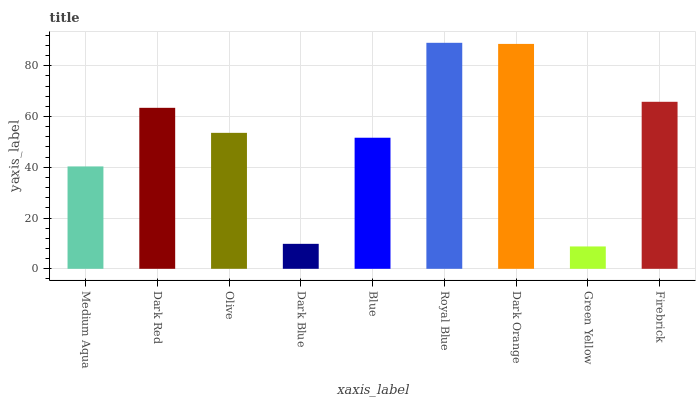Is Green Yellow the minimum?
Answer yes or no. Yes. Is Royal Blue the maximum?
Answer yes or no. Yes. Is Dark Red the minimum?
Answer yes or no. No. Is Dark Red the maximum?
Answer yes or no. No. Is Dark Red greater than Medium Aqua?
Answer yes or no. Yes. Is Medium Aqua less than Dark Red?
Answer yes or no. Yes. Is Medium Aqua greater than Dark Red?
Answer yes or no. No. Is Dark Red less than Medium Aqua?
Answer yes or no. No. Is Olive the high median?
Answer yes or no. Yes. Is Olive the low median?
Answer yes or no. Yes. Is Firebrick the high median?
Answer yes or no. No. Is Green Yellow the low median?
Answer yes or no. No. 